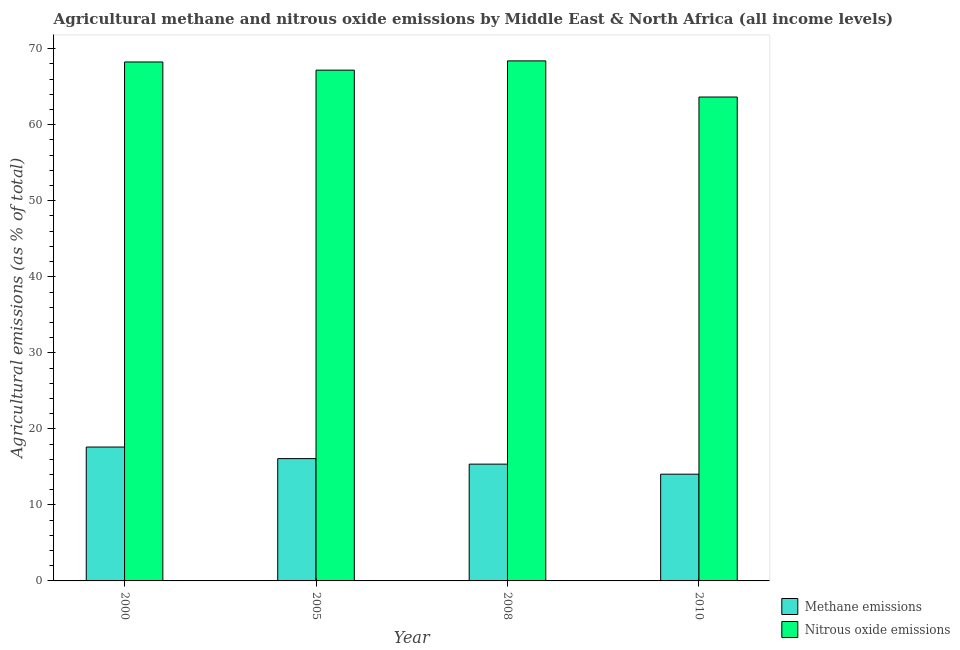Are the number of bars per tick equal to the number of legend labels?
Your response must be concise. Yes. Are the number of bars on each tick of the X-axis equal?
Provide a succinct answer. Yes. How many bars are there on the 2nd tick from the left?
Make the answer very short. 2. In how many cases, is the number of bars for a given year not equal to the number of legend labels?
Your answer should be compact. 0. What is the amount of nitrous oxide emissions in 2005?
Make the answer very short. 67.18. Across all years, what is the maximum amount of methane emissions?
Give a very brief answer. 17.61. Across all years, what is the minimum amount of methane emissions?
Provide a short and direct response. 14.04. In which year was the amount of methane emissions maximum?
Your answer should be very brief. 2000. In which year was the amount of methane emissions minimum?
Provide a short and direct response. 2010. What is the total amount of nitrous oxide emissions in the graph?
Your answer should be compact. 267.48. What is the difference between the amount of nitrous oxide emissions in 2005 and that in 2008?
Provide a succinct answer. -1.22. What is the difference between the amount of nitrous oxide emissions in 2000 and the amount of methane emissions in 2010?
Your answer should be compact. 4.61. What is the average amount of nitrous oxide emissions per year?
Provide a short and direct response. 66.87. In the year 2005, what is the difference between the amount of methane emissions and amount of nitrous oxide emissions?
Provide a short and direct response. 0. What is the ratio of the amount of methane emissions in 2008 to that in 2010?
Ensure brevity in your answer.  1.09. Is the amount of methane emissions in 2008 less than that in 2010?
Ensure brevity in your answer.  No. Is the difference between the amount of nitrous oxide emissions in 2005 and 2010 greater than the difference between the amount of methane emissions in 2005 and 2010?
Provide a short and direct response. No. What is the difference between the highest and the second highest amount of methane emissions?
Your answer should be compact. 1.52. What is the difference between the highest and the lowest amount of methane emissions?
Your response must be concise. 3.57. What does the 1st bar from the left in 2000 represents?
Offer a terse response. Methane emissions. What does the 1st bar from the right in 2010 represents?
Provide a succinct answer. Nitrous oxide emissions. How many bars are there?
Your answer should be very brief. 8. How many years are there in the graph?
Ensure brevity in your answer.  4. Are the values on the major ticks of Y-axis written in scientific E-notation?
Give a very brief answer. No. Where does the legend appear in the graph?
Offer a very short reply. Bottom right. How many legend labels are there?
Provide a short and direct response. 2. What is the title of the graph?
Give a very brief answer. Agricultural methane and nitrous oxide emissions by Middle East & North Africa (all income levels). Does "Secondary school" appear as one of the legend labels in the graph?
Your answer should be compact. No. What is the label or title of the Y-axis?
Your answer should be very brief. Agricultural emissions (as % of total). What is the Agricultural emissions (as % of total) of Methane emissions in 2000?
Keep it short and to the point. 17.61. What is the Agricultural emissions (as % of total) of Nitrous oxide emissions in 2000?
Your response must be concise. 68.25. What is the Agricultural emissions (as % of total) in Methane emissions in 2005?
Your answer should be compact. 16.09. What is the Agricultural emissions (as % of total) in Nitrous oxide emissions in 2005?
Your response must be concise. 67.18. What is the Agricultural emissions (as % of total) in Methane emissions in 2008?
Your answer should be very brief. 15.36. What is the Agricultural emissions (as % of total) in Nitrous oxide emissions in 2008?
Your answer should be very brief. 68.4. What is the Agricultural emissions (as % of total) of Methane emissions in 2010?
Keep it short and to the point. 14.04. What is the Agricultural emissions (as % of total) in Nitrous oxide emissions in 2010?
Your response must be concise. 63.65. Across all years, what is the maximum Agricultural emissions (as % of total) in Methane emissions?
Ensure brevity in your answer.  17.61. Across all years, what is the maximum Agricultural emissions (as % of total) in Nitrous oxide emissions?
Offer a very short reply. 68.4. Across all years, what is the minimum Agricultural emissions (as % of total) of Methane emissions?
Make the answer very short. 14.04. Across all years, what is the minimum Agricultural emissions (as % of total) in Nitrous oxide emissions?
Your response must be concise. 63.65. What is the total Agricultural emissions (as % of total) of Methane emissions in the graph?
Your answer should be very brief. 63.1. What is the total Agricultural emissions (as % of total) in Nitrous oxide emissions in the graph?
Your answer should be compact. 267.48. What is the difference between the Agricultural emissions (as % of total) of Methane emissions in 2000 and that in 2005?
Keep it short and to the point. 1.52. What is the difference between the Agricultural emissions (as % of total) in Nitrous oxide emissions in 2000 and that in 2005?
Keep it short and to the point. 1.07. What is the difference between the Agricultural emissions (as % of total) in Methane emissions in 2000 and that in 2008?
Keep it short and to the point. 2.25. What is the difference between the Agricultural emissions (as % of total) of Nitrous oxide emissions in 2000 and that in 2008?
Provide a short and direct response. -0.15. What is the difference between the Agricultural emissions (as % of total) in Methane emissions in 2000 and that in 2010?
Your answer should be compact. 3.57. What is the difference between the Agricultural emissions (as % of total) in Nitrous oxide emissions in 2000 and that in 2010?
Offer a very short reply. 4.61. What is the difference between the Agricultural emissions (as % of total) in Methane emissions in 2005 and that in 2008?
Offer a very short reply. 0.72. What is the difference between the Agricultural emissions (as % of total) of Nitrous oxide emissions in 2005 and that in 2008?
Offer a terse response. -1.22. What is the difference between the Agricultural emissions (as % of total) in Methane emissions in 2005 and that in 2010?
Your answer should be compact. 2.05. What is the difference between the Agricultural emissions (as % of total) in Nitrous oxide emissions in 2005 and that in 2010?
Provide a short and direct response. 3.54. What is the difference between the Agricultural emissions (as % of total) of Methane emissions in 2008 and that in 2010?
Give a very brief answer. 1.32. What is the difference between the Agricultural emissions (as % of total) of Nitrous oxide emissions in 2008 and that in 2010?
Make the answer very short. 4.76. What is the difference between the Agricultural emissions (as % of total) of Methane emissions in 2000 and the Agricultural emissions (as % of total) of Nitrous oxide emissions in 2005?
Offer a terse response. -49.57. What is the difference between the Agricultural emissions (as % of total) in Methane emissions in 2000 and the Agricultural emissions (as % of total) in Nitrous oxide emissions in 2008?
Provide a succinct answer. -50.79. What is the difference between the Agricultural emissions (as % of total) in Methane emissions in 2000 and the Agricultural emissions (as % of total) in Nitrous oxide emissions in 2010?
Offer a very short reply. -46.04. What is the difference between the Agricultural emissions (as % of total) of Methane emissions in 2005 and the Agricultural emissions (as % of total) of Nitrous oxide emissions in 2008?
Offer a very short reply. -52.31. What is the difference between the Agricultural emissions (as % of total) of Methane emissions in 2005 and the Agricultural emissions (as % of total) of Nitrous oxide emissions in 2010?
Keep it short and to the point. -47.56. What is the difference between the Agricultural emissions (as % of total) of Methane emissions in 2008 and the Agricultural emissions (as % of total) of Nitrous oxide emissions in 2010?
Keep it short and to the point. -48.28. What is the average Agricultural emissions (as % of total) of Methane emissions per year?
Your answer should be very brief. 15.77. What is the average Agricultural emissions (as % of total) of Nitrous oxide emissions per year?
Keep it short and to the point. 66.87. In the year 2000, what is the difference between the Agricultural emissions (as % of total) in Methane emissions and Agricultural emissions (as % of total) in Nitrous oxide emissions?
Provide a short and direct response. -50.65. In the year 2005, what is the difference between the Agricultural emissions (as % of total) of Methane emissions and Agricultural emissions (as % of total) of Nitrous oxide emissions?
Give a very brief answer. -51.1. In the year 2008, what is the difference between the Agricultural emissions (as % of total) in Methane emissions and Agricultural emissions (as % of total) in Nitrous oxide emissions?
Provide a succinct answer. -53.04. In the year 2010, what is the difference between the Agricultural emissions (as % of total) in Methane emissions and Agricultural emissions (as % of total) in Nitrous oxide emissions?
Your response must be concise. -49.6. What is the ratio of the Agricultural emissions (as % of total) in Methane emissions in 2000 to that in 2005?
Offer a terse response. 1.09. What is the ratio of the Agricultural emissions (as % of total) in Methane emissions in 2000 to that in 2008?
Offer a terse response. 1.15. What is the ratio of the Agricultural emissions (as % of total) in Methane emissions in 2000 to that in 2010?
Your response must be concise. 1.25. What is the ratio of the Agricultural emissions (as % of total) in Nitrous oxide emissions in 2000 to that in 2010?
Offer a very short reply. 1.07. What is the ratio of the Agricultural emissions (as % of total) in Methane emissions in 2005 to that in 2008?
Provide a short and direct response. 1.05. What is the ratio of the Agricultural emissions (as % of total) in Nitrous oxide emissions in 2005 to that in 2008?
Keep it short and to the point. 0.98. What is the ratio of the Agricultural emissions (as % of total) in Methane emissions in 2005 to that in 2010?
Provide a succinct answer. 1.15. What is the ratio of the Agricultural emissions (as % of total) in Nitrous oxide emissions in 2005 to that in 2010?
Give a very brief answer. 1.06. What is the ratio of the Agricultural emissions (as % of total) in Methane emissions in 2008 to that in 2010?
Offer a very short reply. 1.09. What is the ratio of the Agricultural emissions (as % of total) of Nitrous oxide emissions in 2008 to that in 2010?
Your answer should be very brief. 1.07. What is the difference between the highest and the second highest Agricultural emissions (as % of total) in Methane emissions?
Make the answer very short. 1.52. What is the difference between the highest and the second highest Agricultural emissions (as % of total) in Nitrous oxide emissions?
Your answer should be very brief. 0.15. What is the difference between the highest and the lowest Agricultural emissions (as % of total) of Methane emissions?
Give a very brief answer. 3.57. What is the difference between the highest and the lowest Agricultural emissions (as % of total) of Nitrous oxide emissions?
Your response must be concise. 4.76. 